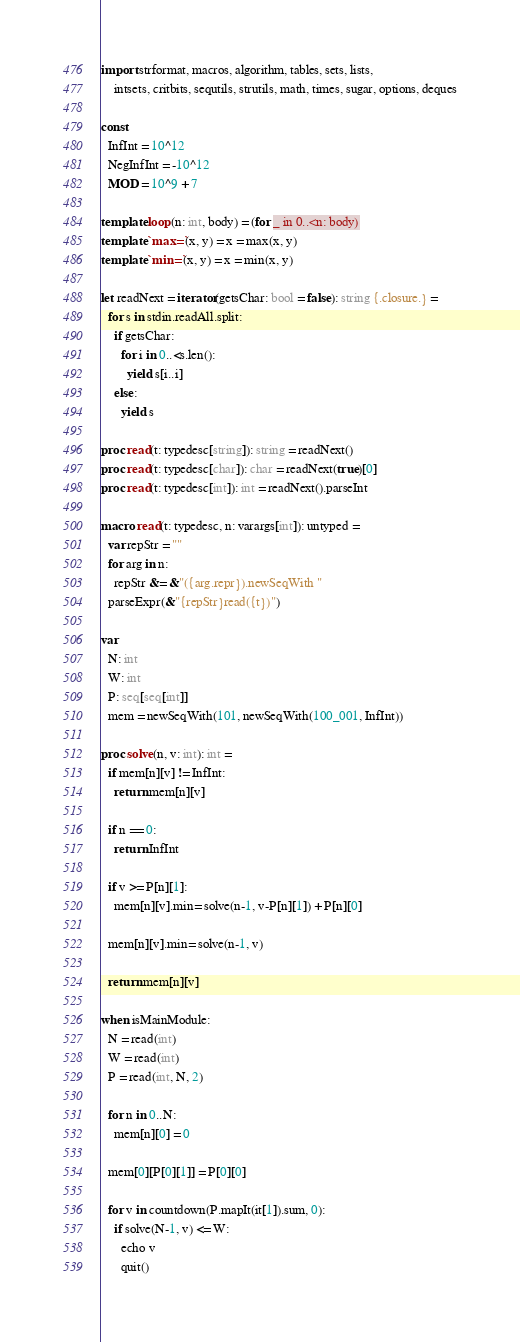Convert code to text. <code><loc_0><loc_0><loc_500><loc_500><_Nim_>import strformat, macros, algorithm, tables, sets, lists,
    intsets, critbits, sequtils, strutils, math, times, sugar, options, deques

const
  InfInt = 10^12
  NegInfInt = -10^12
  MOD = 10^9 + 7

template loop(n: int, body) = (for _ in 0..<n: body)
template `max=`(x, y) = x = max(x, y)
template `min=`(x, y) = x = min(x, y)

let readNext = iterator(getsChar: bool = false): string {.closure.} =
  for s in stdin.readAll.split:
    if getsChar:
      for i in 0..<s.len():
        yield s[i..i]
    else:
      yield s

proc read(t: typedesc[string]): string = readNext()
proc read(t: typedesc[char]): char = readNext(true)[0]
proc read(t: typedesc[int]): int = readNext().parseInt

macro read(t: typedesc, n: varargs[int]): untyped =
  var repStr = ""
  for arg in n:
    repStr &= &"({arg.repr}).newSeqWith "
  parseExpr(&"{repStr}read({t})")

var
  N: int
  W: int
  P: seq[seq[int]]
  mem = newSeqWith(101, newSeqWith(100_001, InfInt))

proc solve(n, v: int): int =
  if mem[n][v] != InfInt:
    return mem[n][v]

  if n == 0:
    return InfInt

  if v >= P[n][1]:
    mem[n][v].min= solve(n-1, v-P[n][1]) + P[n][0]

  mem[n][v].min= solve(n-1, v)

  return mem[n][v]

when isMainModule:
  N = read(int)
  W = read(int)
  P = read(int, N, 2)

  for n in 0..N:
    mem[n][0] = 0

  mem[0][P[0][1]] = P[0][0]

  for v in countdown(P.mapIt(it[1]).sum, 0):
    if solve(N-1, v) <= W:
      echo v
      quit()
</code> 